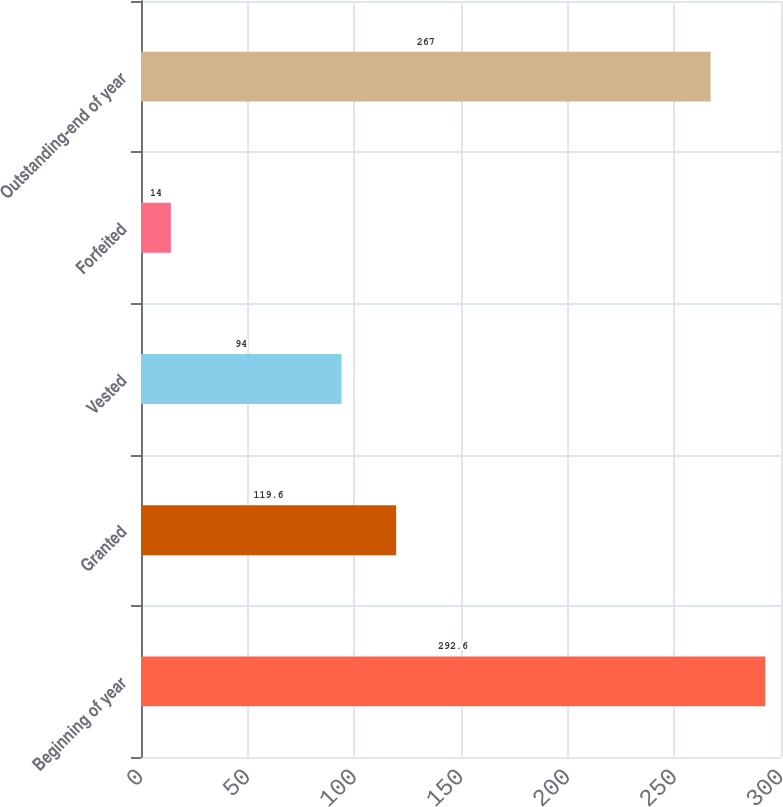Convert chart. <chart><loc_0><loc_0><loc_500><loc_500><bar_chart><fcel>Beginning of year<fcel>Granted<fcel>Vested<fcel>Forfeited<fcel>Outstanding-end of year<nl><fcel>292.6<fcel>119.6<fcel>94<fcel>14<fcel>267<nl></chart> 